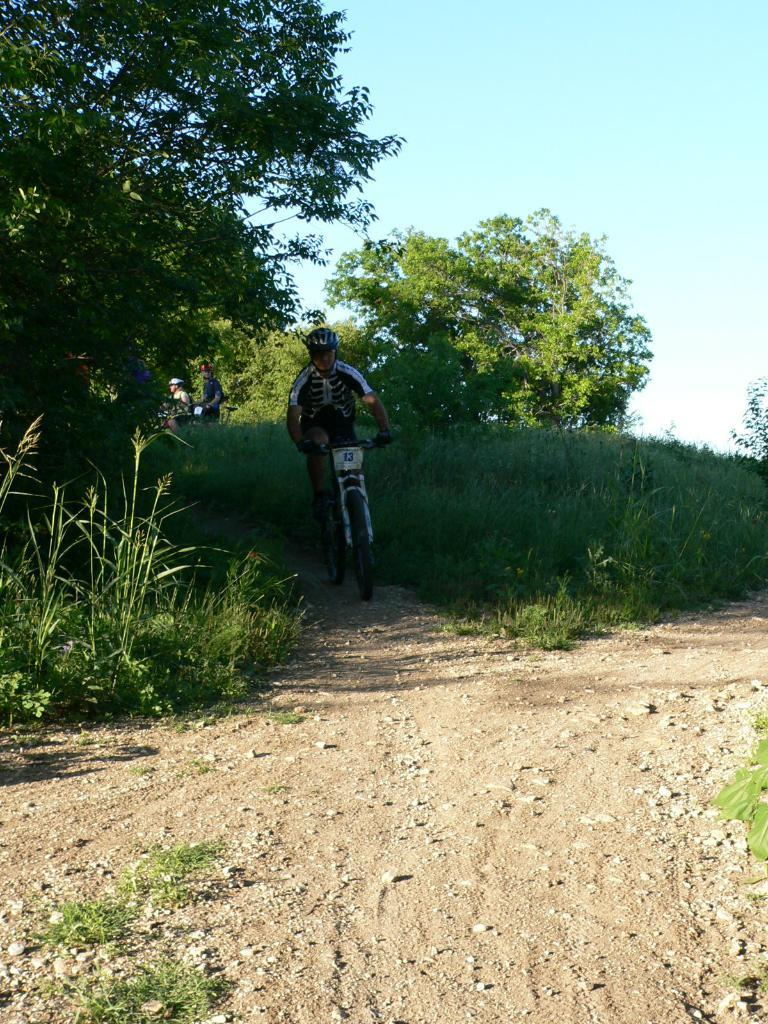What is the main subject of the image? There is a person riding a bicycle in the image. What type of terrain is visible in the image? There is grass in the image. What other types of vegetation can be seen? There are plants and trees in the image. Are there any other people in the image? Yes, there are other persons in the image. What is visible in the background of the image? The sky is visible in the background of the image. What type of home can be seen in the image? There is no home present in the image; it features a person riding a bicycle in a natural setting. What does the tongue of the person riding the bicycle look like in the image? There is no visible tongue of the person riding the bicycle in the image. 